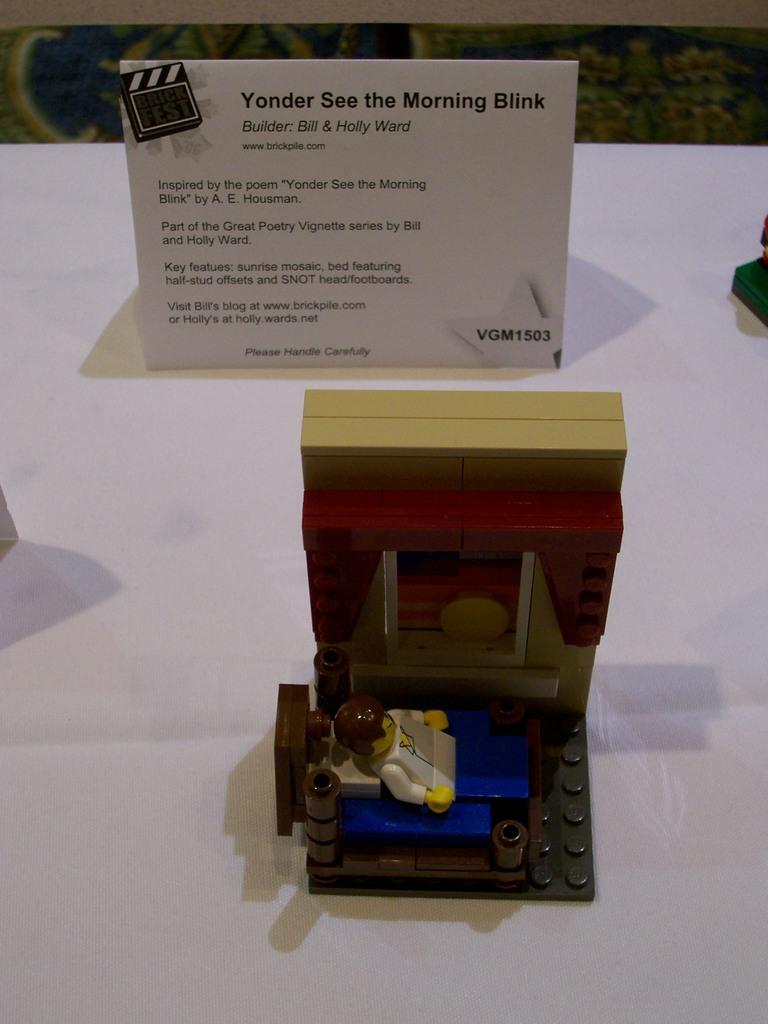What is the label card's title?
Your response must be concise. Yonder see the morning blink. What is written on the bottom right of the card?
Keep it short and to the point. Vgm1503. 